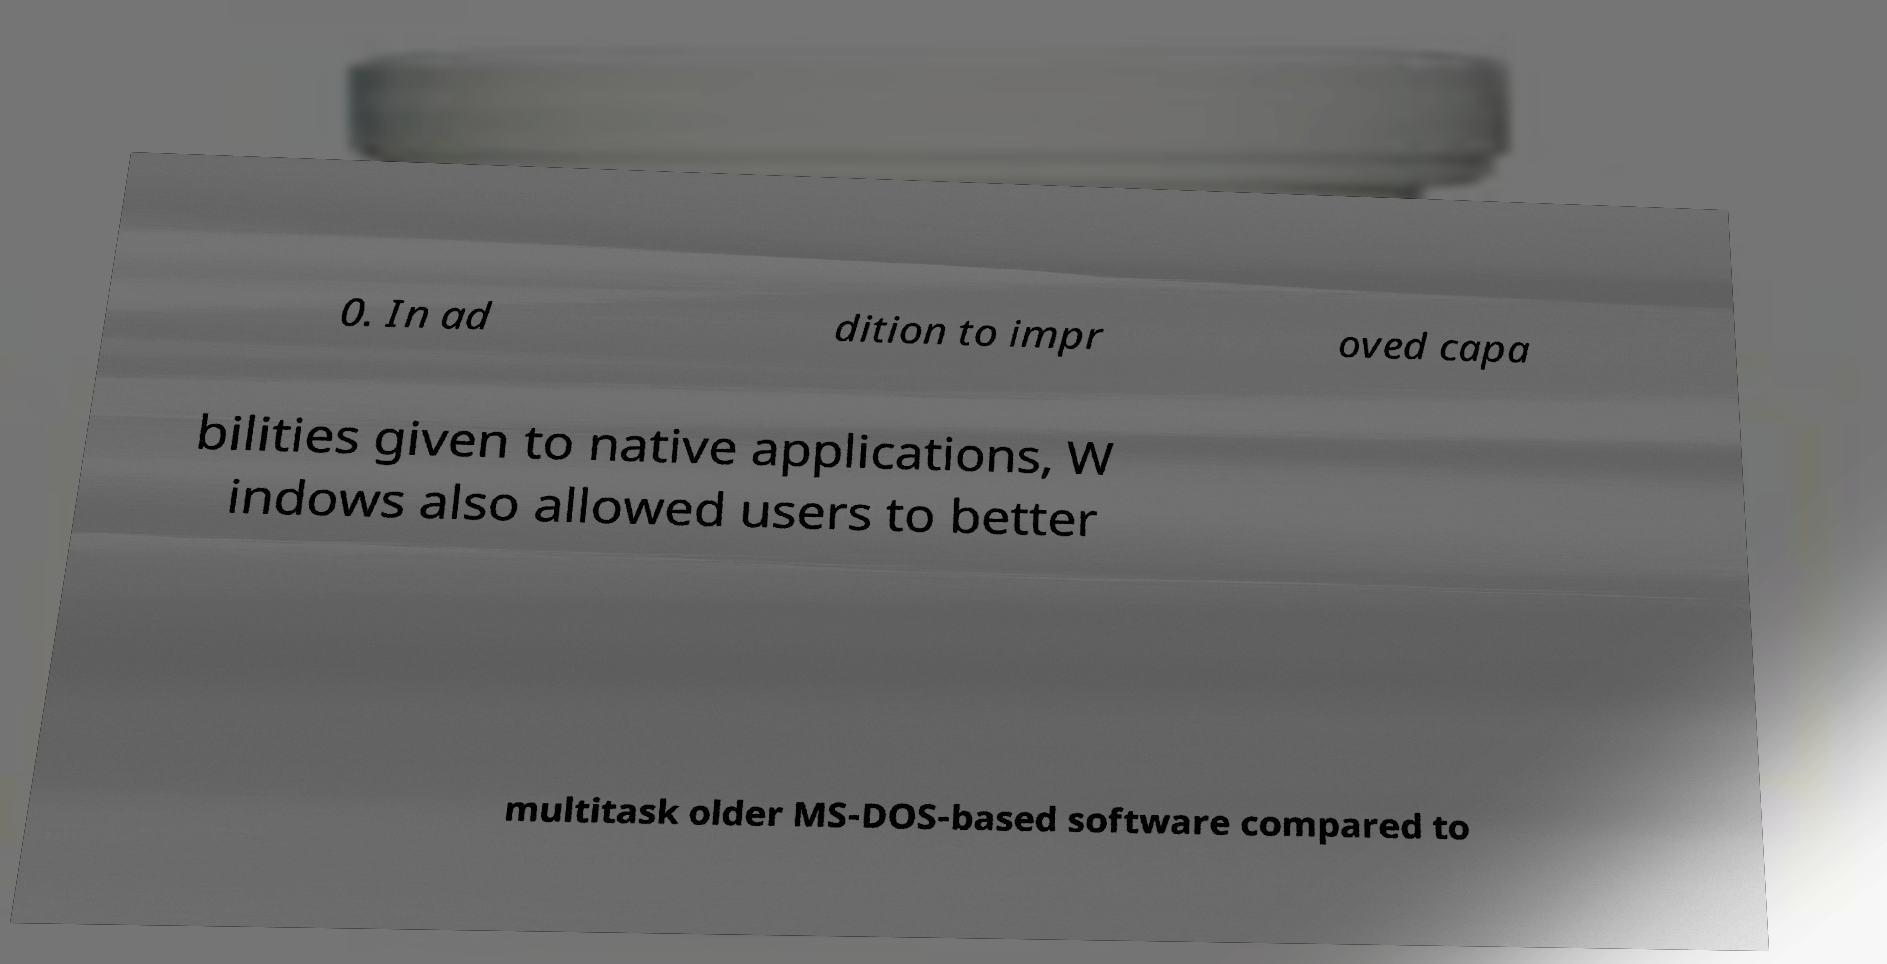Could you extract and type out the text from this image? 0. In ad dition to impr oved capa bilities given to native applications, W indows also allowed users to better multitask older MS-DOS-based software compared to 